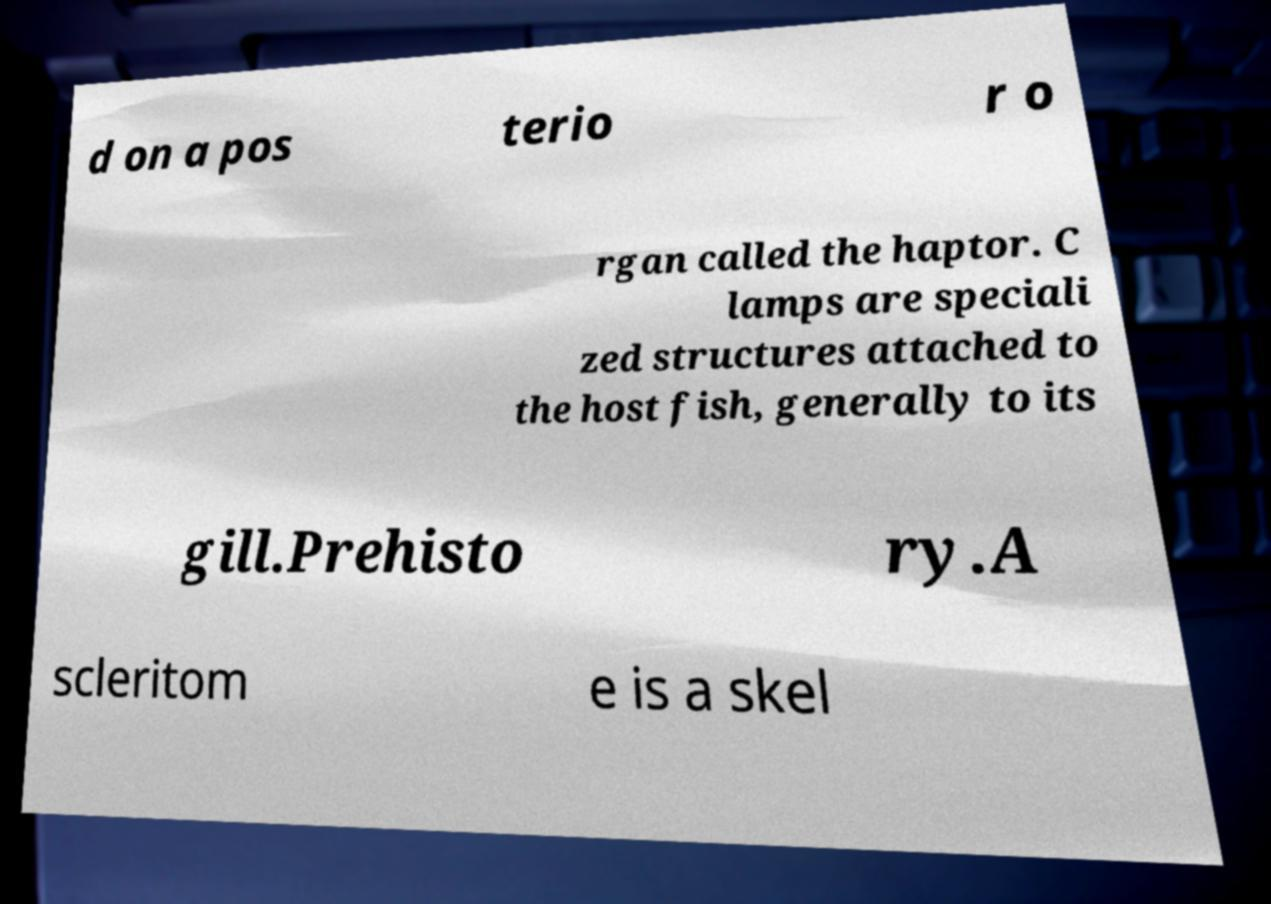Can you read and provide the text displayed in the image?This photo seems to have some interesting text. Can you extract and type it out for me? d on a pos terio r o rgan called the haptor. C lamps are speciali zed structures attached to the host fish, generally to its gill.Prehisto ry.A scleritom e is a skel 